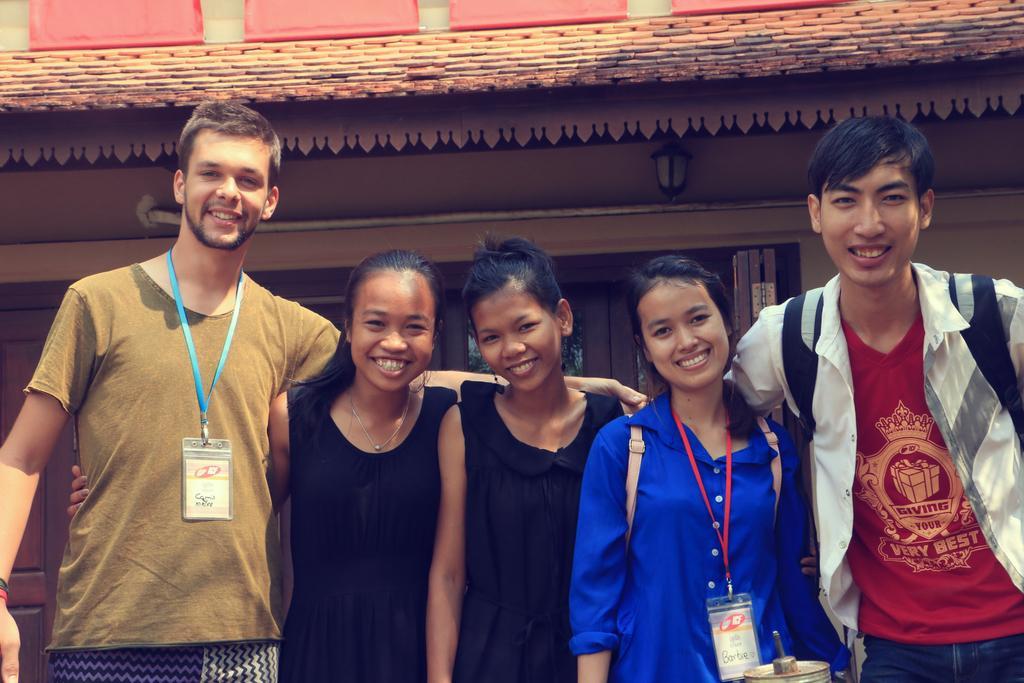Please provide a concise description of this image. There are five persons standing and there is a building behind them. 